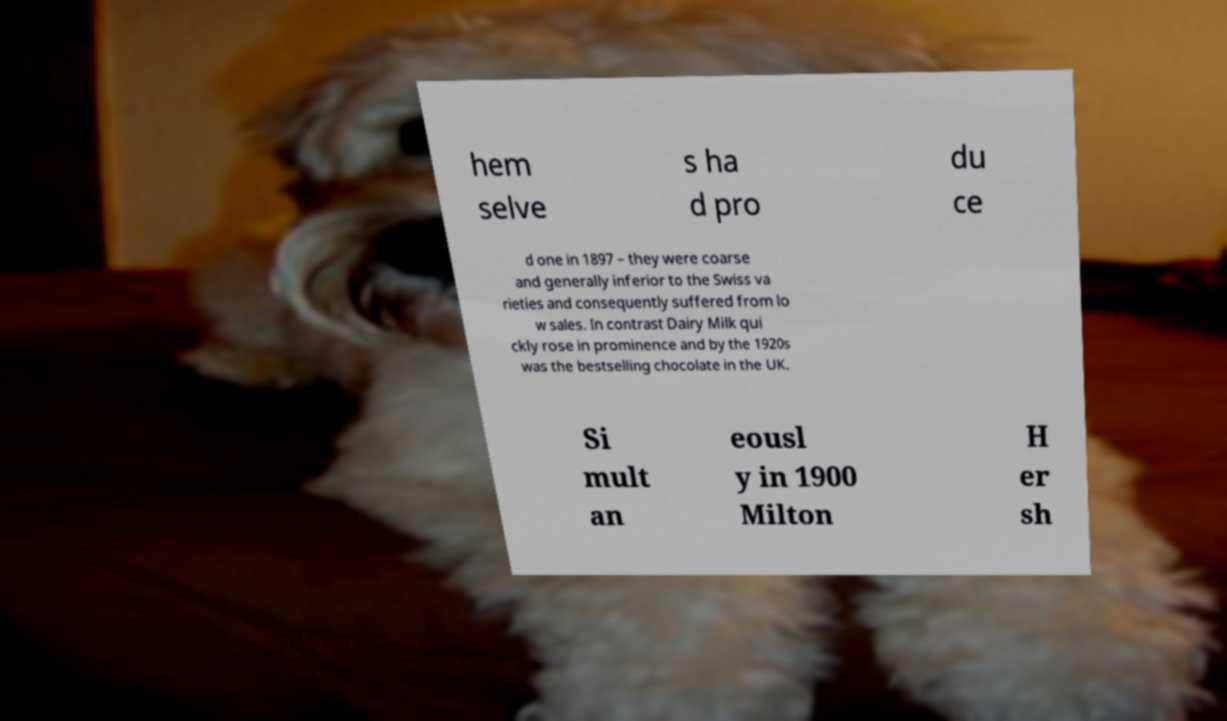Please read and relay the text visible in this image. What does it say? hem selve s ha d pro du ce d one in 1897 – they were coarse and generally inferior to the Swiss va rieties and consequently suffered from lo w sales. In contrast Dairy Milk qui ckly rose in prominence and by the 1920s was the bestselling chocolate in the UK. Si mult an eousl y in 1900 Milton H er sh 